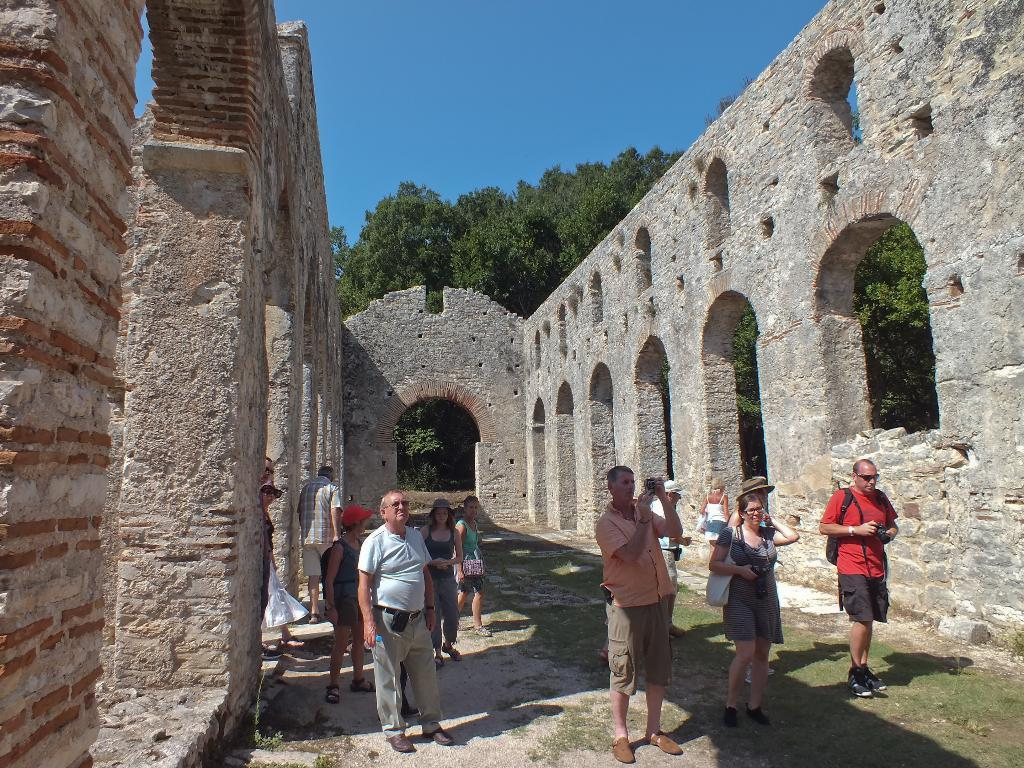How many people are visible in the image? There are people standing in the image, but the exact number is not specified. What is one person doing in the image? One person is holding a camera. What is the person holding the camera wearing? The person holding the camera is wearing a bag. What type of structure can be seen in the image? There is a fort in the image. What type of vegetation is present in the image? Trees are present in the image. What is the color of the sky in the image? The sky is blue in color. What type of pencil can be seen in the mouth of the person holding the camera? There is no pencil visible in the image, and no one is holding a pencil in their mouth. 